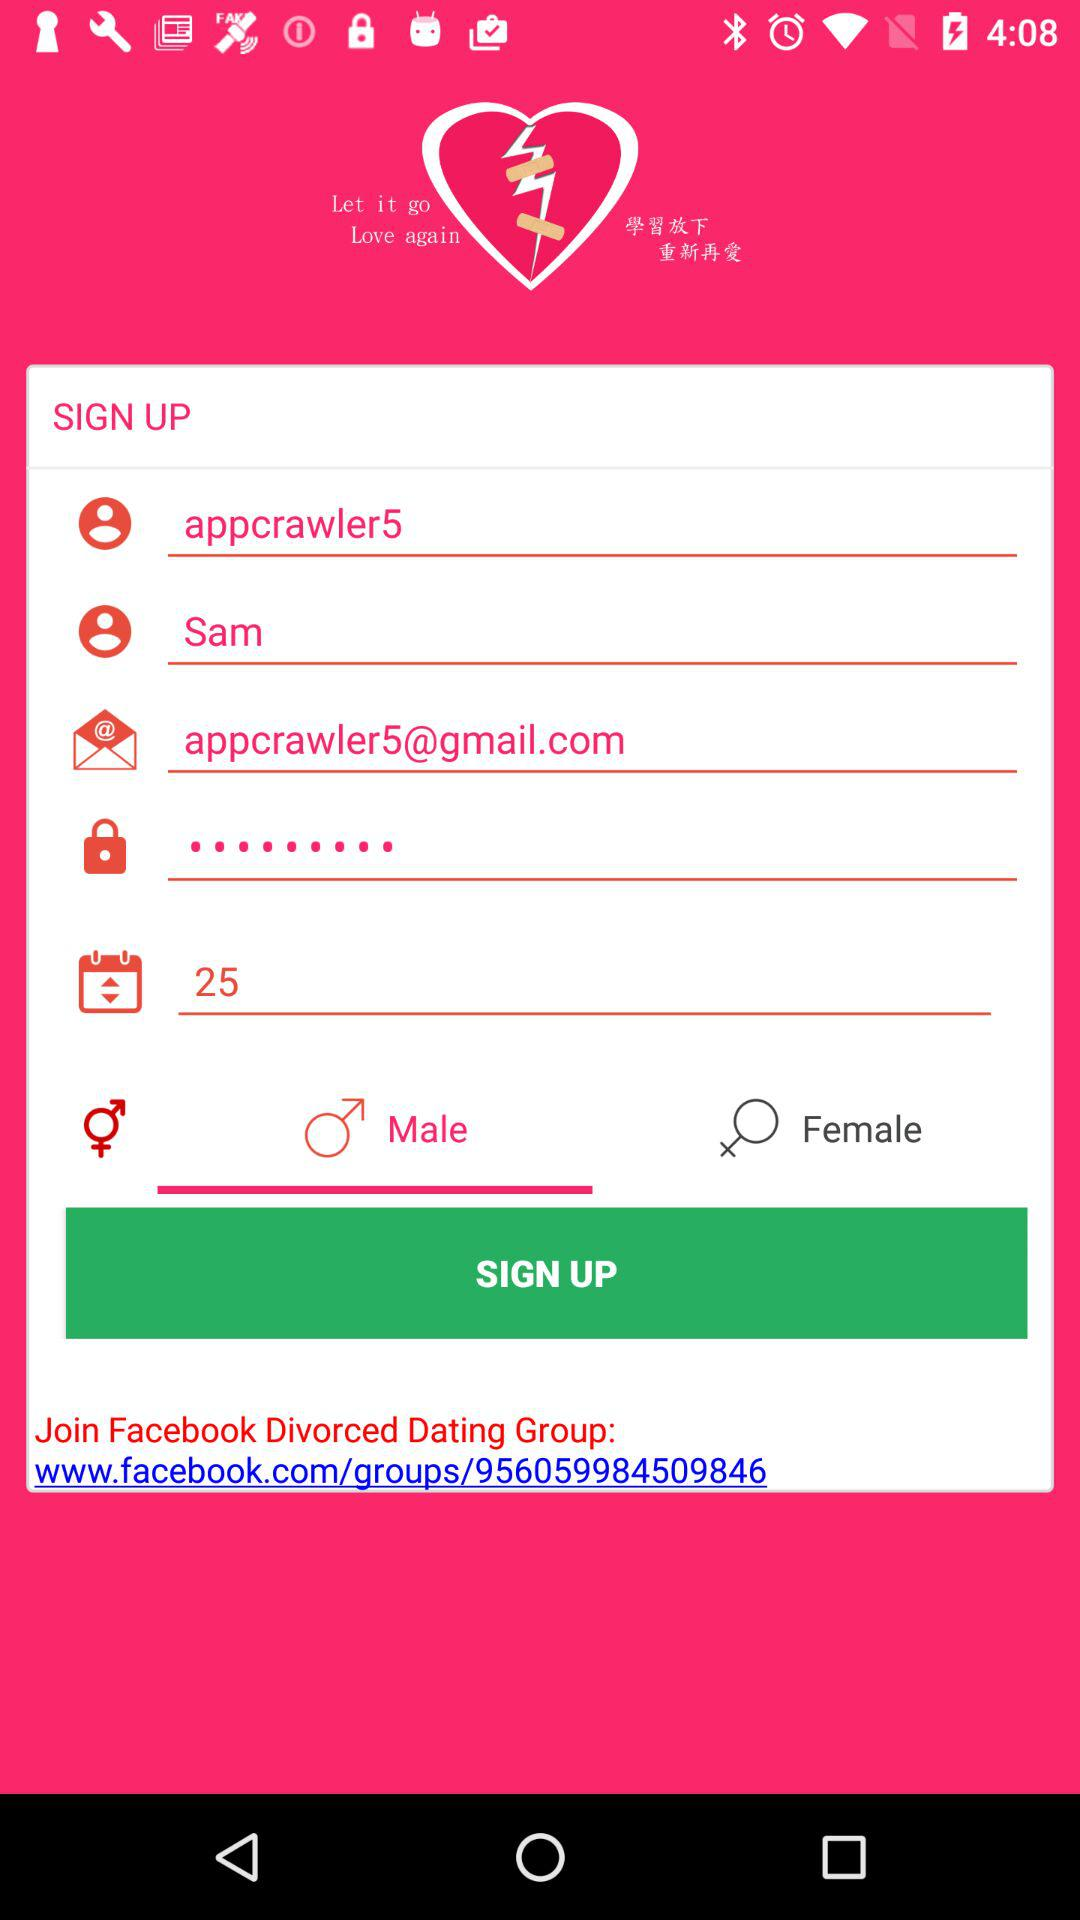What is the email address? The email address is appcrawler5@gmail.com. 